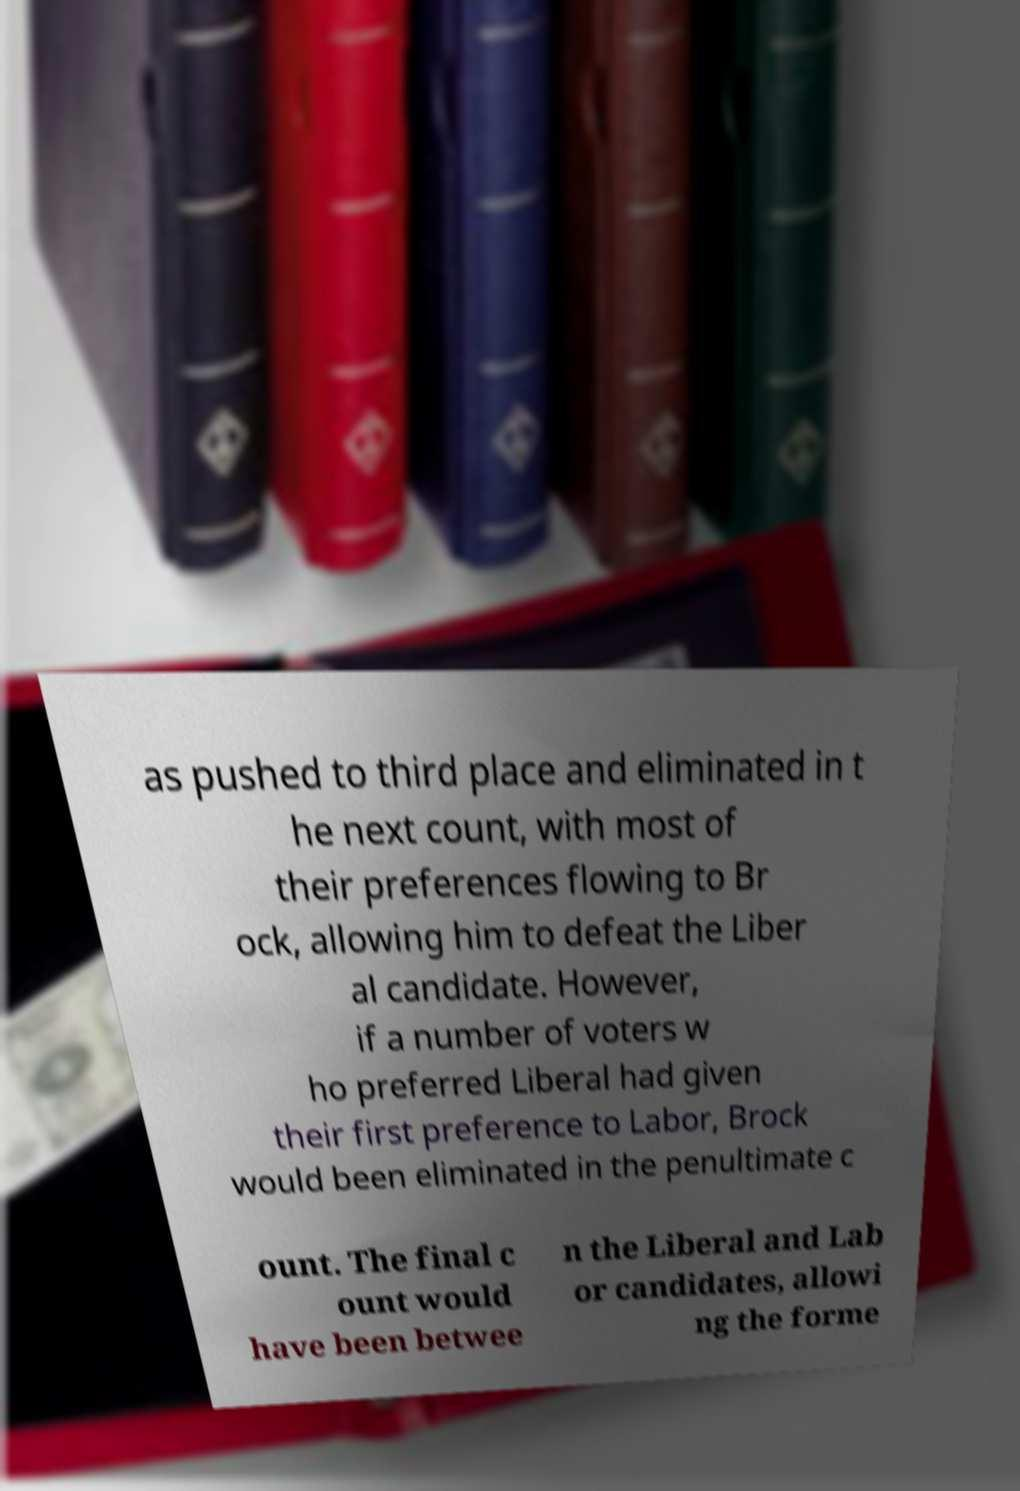Can you accurately transcribe the text from the provided image for me? as pushed to third place and eliminated in t he next count, with most of their preferences flowing to Br ock, allowing him to defeat the Liber al candidate. However, if a number of voters w ho preferred Liberal had given their first preference to Labor, Brock would been eliminated in the penultimate c ount. The final c ount would have been betwee n the Liberal and Lab or candidates, allowi ng the forme 